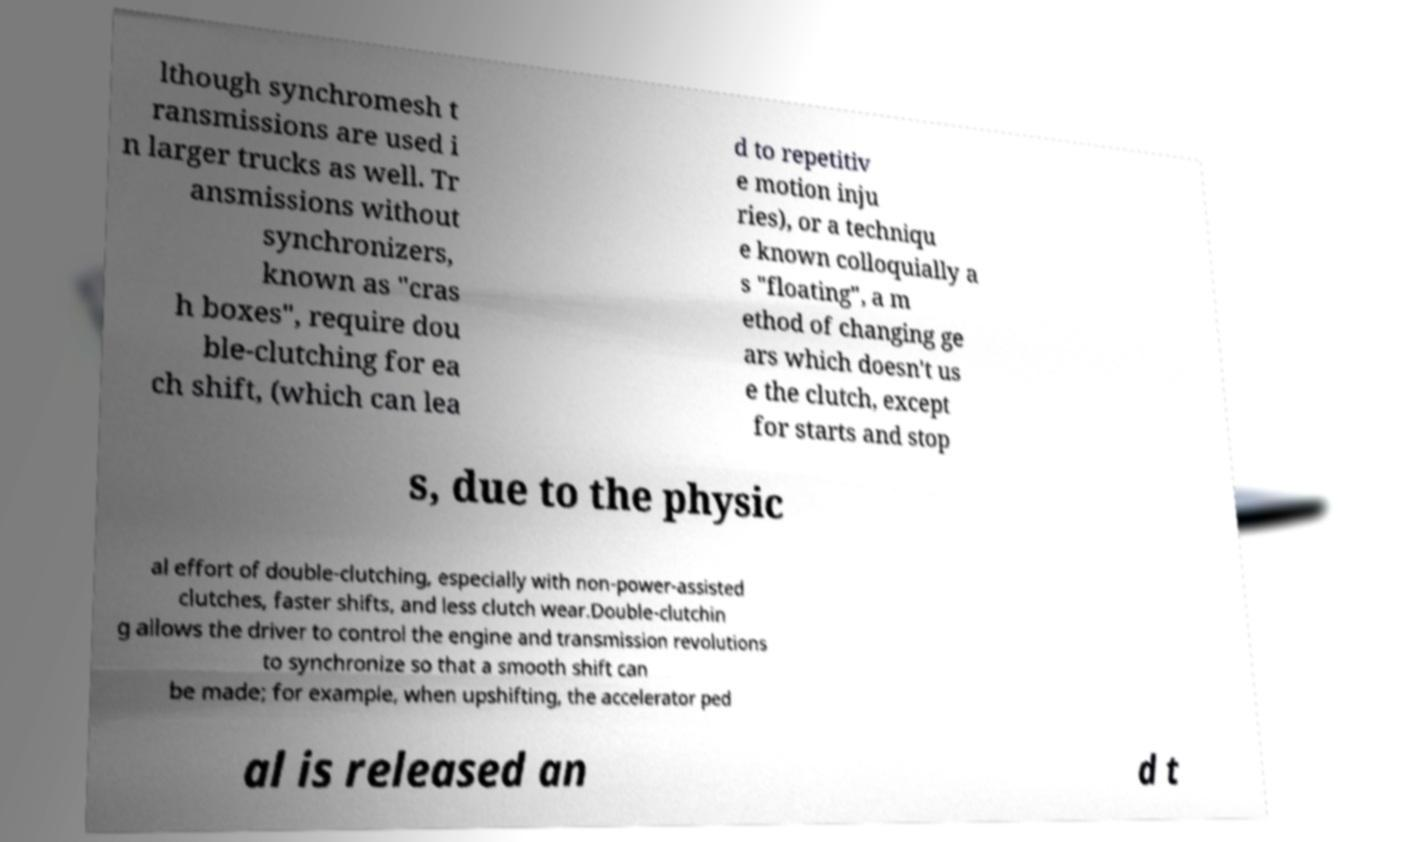I need the written content from this picture converted into text. Can you do that? lthough synchromesh t ransmissions are used i n larger trucks as well. Tr ansmissions without synchronizers, known as "cras h boxes", require dou ble-clutching for ea ch shift, (which can lea d to repetitiv e motion inju ries), or a techniqu e known colloquially a s "floating", a m ethod of changing ge ars which doesn't us e the clutch, except for starts and stop s, due to the physic al effort of double-clutching, especially with non-power-assisted clutches, faster shifts, and less clutch wear.Double-clutchin g allows the driver to control the engine and transmission revolutions to synchronize so that a smooth shift can be made; for example, when upshifting, the accelerator ped al is released an d t 